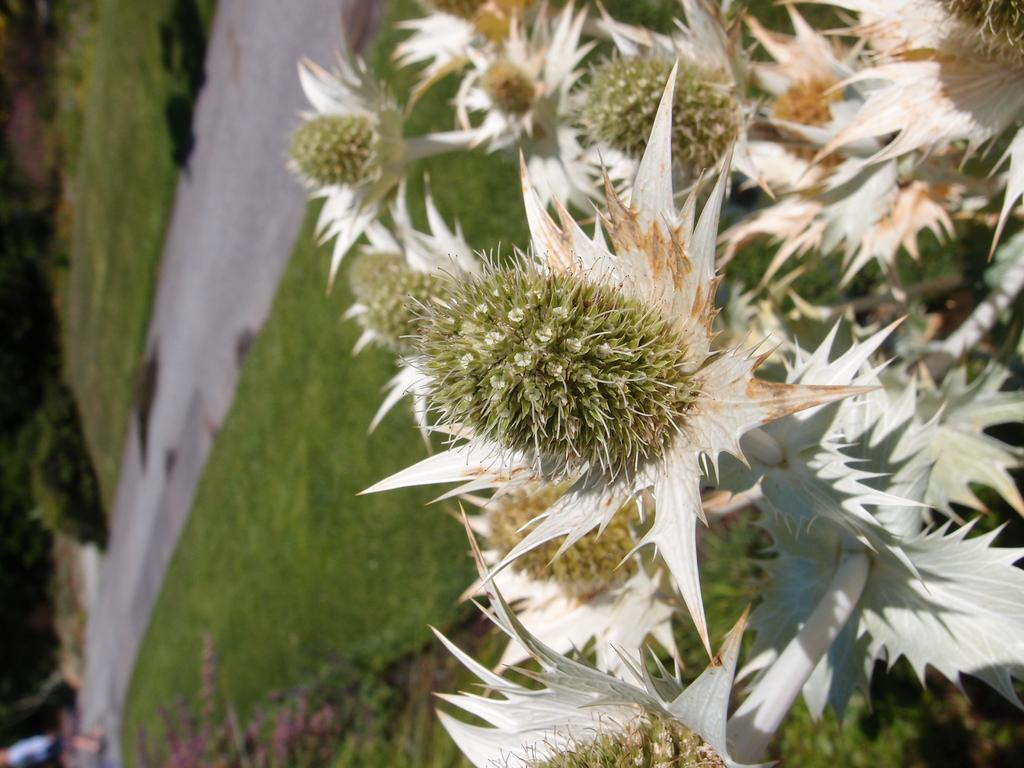What type of vegetation can be seen on the right side of the image? There are flowers on the right side of the image. What can be seen in the background of the image? There is grass and a road in the background of the image. Where is the sink located in the image? There is no sink present in the image. What type of plate is being used by the flowers in the image? There are no plates present in the image, as it features flowers and a background with grass and a road. 